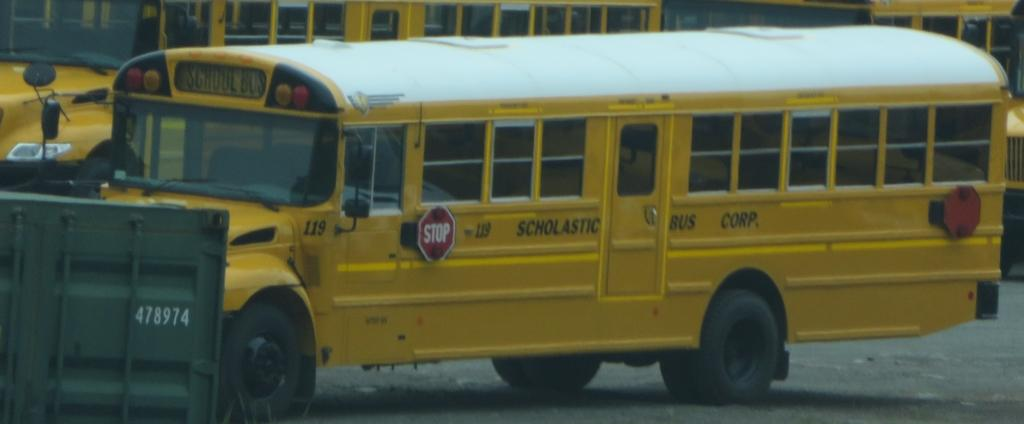<image>
Write a terse but informative summary of the picture. a bus that had the word scholastic on the side 